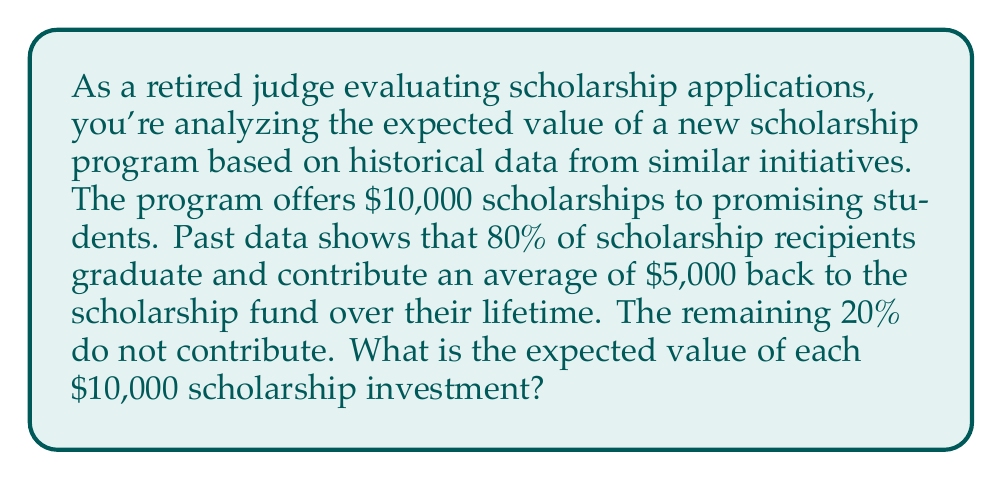Solve this math problem. To solve this problem, we need to calculate the expected value of the scholarship investment using the given probabilities and potential outcomes. Let's break it down step-by-step:

1. Define the possible outcomes:
   - Outcome A: Student graduates and contributes (80% probability)
   - Outcome B: Student does not contribute (20% probability)

2. Calculate the net return for each outcome:
   - Outcome A: $5,000 contribution - $10,000 investment = -$5,000
   - Outcome B: $0 contribution - $10,000 investment = -$10,000

3. Apply the expected value formula:
   $$ E(X) = \sum_{i=1}^n p_i x_i $$
   Where:
   - $E(X)$ is the expected value
   - $p_i$ is the probability of each outcome
   - $x_i$ is the value of each outcome

4. Plug in the values:
   $$ E(X) = (0.80 \times -5000) + (0.20 \times -10000) $$

5. Calculate:
   $$ E(X) = -4000 - 2000 = -6000 $$

Therefore, the expected value of each $10,000 scholarship investment is -$6,000.
Answer: $-6,000 